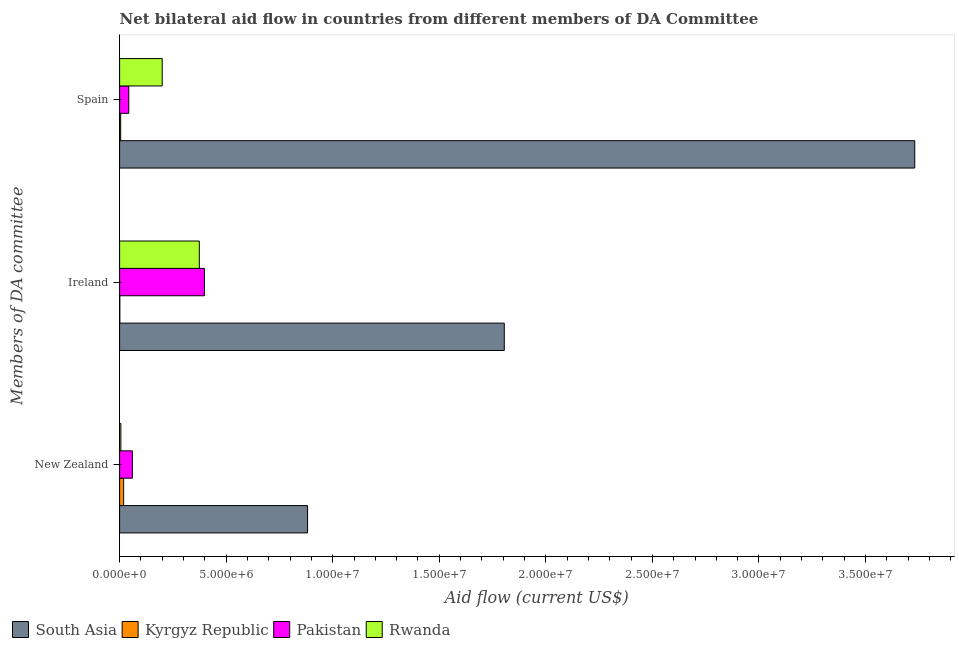Are the number of bars per tick equal to the number of legend labels?
Ensure brevity in your answer.  Yes. Are the number of bars on each tick of the Y-axis equal?
Make the answer very short. Yes. What is the label of the 1st group of bars from the top?
Provide a short and direct response. Spain. What is the amount of aid provided by spain in Kyrgyz Republic?
Keep it short and to the point. 5.00e+04. Across all countries, what is the maximum amount of aid provided by ireland?
Your response must be concise. 1.80e+07. Across all countries, what is the minimum amount of aid provided by ireland?
Keep it short and to the point. 10000. In which country was the amount of aid provided by new zealand minimum?
Ensure brevity in your answer.  Rwanda. What is the total amount of aid provided by ireland in the graph?
Your answer should be very brief. 2.58e+07. What is the difference between the amount of aid provided by ireland in South Asia and that in Pakistan?
Offer a terse response. 1.41e+07. What is the difference between the amount of aid provided by spain in South Asia and the amount of aid provided by ireland in Pakistan?
Your answer should be compact. 3.33e+07. What is the average amount of aid provided by spain per country?
Provide a short and direct response. 9.95e+06. What is the difference between the amount of aid provided by spain and amount of aid provided by ireland in Pakistan?
Your answer should be compact. -3.55e+06. In how many countries, is the amount of aid provided by spain greater than 24000000 US$?
Keep it short and to the point. 1. What is the ratio of the amount of aid provided by ireland in Kyrgyz Republic to that in South Asia?
Your response must be concise. 0. Is the difference between the amount of aid provided by ireland in Kyrgyz Republic and Rwanda greater than the difference between the amount of aid provided by new zealand in Kyrgyz Republic and Rwanda?
Give a very brief answer. No. What is the difference between the highest and the second highest amount of aid provided by new zealand?
Provide a succinct answer. 8.22e+06. What is the difference between the highest and the lowest amount of aid provided by spain?
Offer a terse response. 3.73e+07. What does the 3rd bar from the top in Spain represents?
Keep it short and to the point. Kyrgyz Republic. What does the 1st bar from the bottom in Ireland represents?
Provide a short and direct response. South Asia. Is it the case that in every country, the sum of the amount of aid provided by new zealand and amount of aid provided by ireland is greater than the amount of aid provided by spain?
Make the answer very short. No. What is the difference between two consecutive major ticks on the X-axis?
Provide a succinct answer. 5.00e+06. Does the graph contain any zero values?
Provide a short and direct response. No. How many legend labels are there?
Make the answer very short. 4. What is the title of the graph?
Offer a very short reply. Net bilateral aid flow in countries from different members of DA Committee. Does "Antigua and Barbuda" appear as one of the legend labels in the graph?
Your answer should be very brief. No. What is the label or title of the Y-axis?
Keep it short and to the point. Members of DA committee. What is the Aid flow (current US$) in South Asia in New Zealand?
Make the answer very short. 8.82e+06. What is the Aid flow (current US$) in Kyrgyz Republic in New Zealand?
Give a very brief answer. 1.90e+05. What is the Aid flow (current US$) in Pakistan in New Zealand?
Offer a terse response. 6.00e+05. What is the Aid flow (current US$) of Rwanda in New Zealand?
Offer a terse response. 6.00e+04. What is the Aid flow (current US$) in South Asia in Ireland?
Your answer should be very brief. 1.80e+07. What is the Aid flow (current US$) of Pakistan in Ireland?
Your response must be concise. 3.98e+06. What is the Aid flow (current US$) in Rwanda in Ireland?
Your answer should be compact. 3.74e+06. What is the Aid flow (current US$) of South Asia in Spain?
Keep it short and to the point. 3.73e+07. What is the Aid flow (current US$) in Pakistan in Spain?
Give a very brief answer. 4.30e+05. Across all Members of DA committee, what is the maximum Aid flow (current US$) of South Asia?
Provide a short and direct response. 3.73e+07. Across all Members of DA committee, what is the maximum Aid flow (current US$) in Pakistan?
Give a very brief answer. 3.98e+06. Across all Members of DA committee, what is the maximum Aid flow (current US$) in Rwanda?
Offer a very short reply. 3.74e+06. Across all Members of DA committee, what is the minimum Aid flow (current US$) of South Asia?
Your response must be concise. 8.82e+06. Across all Members of DA committee, what is the minimum Aid flow (current US$) of Kyrgyz Republic?
Your response must be concise. 10000. Across all Members of DA committee, what is the minimum Aid flow (current US$) of Rwanda?
Your answer should be very brief. 6.00e+04. What is the total Aid flow (current US$) in South Asia in the graph?
Make the answer very short. 6.42e+07. What is the total Aid flow (current US$) of Kyrgyz Republic in the graph?
Provide a succinct answer. 2.50e+05. What is the total Aid flow (current US$) of Pakistan in the graph?
Offer a very short reply. 5.01e+06. What is the total Aid flow (current US$) of Rwanda in the graph?
Offer a terse response. 5.80e+06. What is the difference between the Aid flow (current US$) of South Asia in New Zealand and that in Ireland?
Your response must be concise. -9.23e+06. What is the difference between the Aid flow (current US$) of Pakistan in New Zealand and that in Ireland?
Offer a terse response. -3.38e+06. What is the difference between the Aid flow (current US$) in Rwanda in New Zealand and that in Ireland?
Make the answer very short. -3.68e+06. What is the difference between the Aid flow (current US$) of South Asia in New Zealand and that in Spain?
Keep it short and to the point. -2.85e+07. What is the difference between the Aid flow (current US$) of Pakistan in New Zealand and that in Spain?
Your answer should be compact. 1.70e+05. What is the difference between the Aid flow (current US$) in Rwanda in New Zealand and that in Spain?
Your answer should be compact. -1.94e+06. What is the difference between the Aid flow (current US$) in South Asia in Ireland and that in Spain?
Give a very brief answer. -1.93e+07. What is the difference between the Aid flow (current US$) in Kyrgyz Republic in Ireland and that in Spain?
Your answer should be very brief. -4.00e+04. What is the difference between the Aid flow (current US$) in Pakistan in Ireland and that in Spain?
Your answer should be very brief. 3.55e+06. What is the difference between the Aid flow (current US$) of Rwanda in Ireland and that in Spain?
Ensure brevity in your answer.  1.74e+06. What is the difference between the Aid flow (current US$) in South Asia in New Zealand and the Aid flow (current US$) in Kyrgyz Republic in Ireland?
Your answer should be compact. 8.81e+06. What is the difference between the Aid flow (current US$) in South Asia in New Zealand and the Aid flow (current US$) in Pakistan in Ireland?
Keep it short and to the point. 4.84e+06. What is the difference between the Aid flow (current US$) in South Asia in New Zealand and the Aid flow (current US$) in Rwanda in Ireland?
Ensure brevity in your answer.  5.08e+06. What is the difference between the Aid flow (current US$) in Kyrgyz Republic in New Zealand and the Aid flow (current US$) in Pakistan in Ireland?
Your answer should be very brief. -3.79e+06. What is the difference between the Aid flow (current US$) of Kyrgyz Republic in New Zealand and the Aid flow (current US$) of Rwanda in Ireland?
Give a very brief answer. -3.55e+06. What is the difference between the Aid flow (current US$) of Pakistan in New Zealand and the Aid flow (current US$) of Rwanda in Ireland?
Keep it short and to the point. -3.14e+06. What is the difference between the Aid flow (current US$) in South Asia in New Zealand and the Aid flow (current US$) in Kyrgyz Republic in Spain?
Offer a terse response. 8.77e+06. What is the difference between the Aid flow (current US$) in South Asia in New Zealand and the Aid flow (current US$) in Pakistan in Spain?
Your answer should be very brief. 8.39e+06. What is the difference between the Aid flow (current US$) in South Asia in New Zealand and the Aid flow (current US$) in Rwanda in Spain?
Provide a succinct answer. 6.82e+06. What is the difference between the Aid flow (current US$) in Kyrgyz Republic in New Zealand and the Aid flow (current US$) in Pakistan in Spain?
Offer a terse response. -2.40e+05. What is the difference between the Aid flow (current US$) of Kyrgyz Republic in New Zealand and the Aid flow (current US$) of Rwanda in Spain?
Provide a succinct answer. -1.81e+06. What is the difference between the Aid flow (current US$) in Pakistan in New Zealand and the Aid flow (current US$) in Rwanda in Spain?
Give a very brief answer. -1.40e+06. What is the difference between the Aid flow (current US$) of South Asia in Ireland and the Aid flow (current US$) of Kyrgyz Republic in Spain?
Keep it short and to the point. 1.80e+07. What is the difference between the Aid flow (current US$) in South Asia in Ireland and the Aid flow (current US$) in Pakistan in Spain?
Offer a terse response. 1.76e+07. What is the difference between the Aid flow (current US$) of South Asia in Ireland and the Aid flow (current US$) of Rwanda in Spain?
Your answer should be compact. 1.60e+07. What is the difference between the Aid flow (current US$) in Kyrgyz Republic in Ireland and the Aid flow (current US$) in Pakistan in Spain?
Provide a succinct answer. -4.20e+05. What is the difference between the Aid flow (current US$) in Kyrgyz Republic in Ireland and the Aid flow (current US$) in Rwanda in Spain?
Keep it short and to the point. -1.99e+06. What is the difference between the Aid flow (current US$) of Pakistan in Ireland and the Aid flow (current US$) of Rwanda in Spain?
Provide a succinct answer. 1.98e+06. What is the average Aid flow (current US$) in South Asia per Members of DA committee?
Give a very brief answer. 2.14e+07. What is the average Aid flow (current US$) of Kyrgyz Republic per Members of DA committee?
Your answer should be very brief. 8.33e+04. What is the average Aid flow (current US$) of Pakistan per Members of DA committee?
Provide a succinct answer. 1.67e+06. What is the average Aid flow (current US$) of Rwanda per Members of DA committee?
Provide a succinct answer. 1.93e+06. What is the difference between the Aid flow (current US$) in South Asia and Aid flow (current US$) in Kyrgyz Republic in New Zealand?
Give a very brief answer. 8.63e+06. What is the difference between the Aid flow (current US$) in South Asia and Aid flow (current US$) in Pakistan in New Zealand?
Offer a terse response. 8.22e+06. What is the difference between the Aid flow (current US$) in South Asia and Aid flow (current US$) in Rwanda in New Zealand?
Your answer should be compact. 8.76e+06. What is the difference between the Aid flow (current US$) of Kyrgyz Republic and Aid flow (current US$) of Pakistan in New Zealand?
Your response must be concise. -4.10e+05. What is the difference between the Aid flow (current US$) of Pakistan and Aid flow (current US$) of Rwanda in New Zealand?
Give a very brief answer. 5.40e+05. What is the difference between the Aid flow (current US$) of South Asia and Aid flow (current US$) of Kyrgyz Republic in Ireland?
Offer a very short reply. 1.80e+07. What is the difference between the Aid flow (current US$) in South Asia and Aid flow (current US$) in Pakistan in Ireland?
Your answer should be compact. 1.41e+07. What is the difference between the Aid flow (current US$) of South Asia and Aid flow (current US$) of Rwanda in Ireland?
Provide a succinct answer. 1.43e+07. What is the difference between the Aid flow (current US$) of Kyrgyz Republic and Aid flow (current US$) of Pakistan in Ireland?
Provide a succinct answer. -3.97e+06. What is the difference between the Aid flow (current US$) of Kyrgyz Republic and Aid flow (current US$) of Rwanda in Ireland?
Provide a succinct answer. -3.73e+06. What is the difference between the Aid flow (current US$) of Pakistan and Aid flow (current US$) of Rwanda in Ireland?
Your answer should be very brief. 2.40e+05. What is the difference between the Aid flow (current US$) in South Asia and Aid flow (current US$) in Kyrgyz Republic in Spain?
Offer a very short reply. 3.73e+07. What is the difference between the Aid flow (current US$) in South Asia and Aid flow (current US$) in Pakistan in Spain?
Provide a short and direct response. 3.69e+07. What is the difference between the Aid flow (current US$) of South Asia and Aid flow (current US$) of Rwanda in Spain?
Your answer should be very brief. 3.53e+07. What is the difference between the Aid flow (current US$) in Kyrgyz Republic and Aid flow (current US$) in Pakistan in Spain?
Your answer should be very brief. -3.80e+05. What is the difference between the Aid flow (current US$) of Kyrgyz Republic and Aid flow (current US$) of Rwanda in Spain?
Offer a terse response. -1.95e+06. What is the difference between the Aid flow (current US$) in Pakistan and Aid flow (current US$) in Rwanda in Spain?
Provide a short and direct response. -1.57e+06. What is the ratio of the Aid flow (current US$) in South Asia in New Zealand to that in Ireland?
Your response must be concise. 0.49. What is the ratio of the Aid flow (current US$) of Kyrgyz Republic in New Zealand to that in Ireland?
Your answer should be very brief. 19. What is the ratio of the Aid flow (current US$) in Pakistan in New Zealand to that in Ireland?
Ensure brevity in your answer.  0.15. What is the ratio of the Aid flow (current US$) in Rwanda in New Zealand to that in Ireland?
Offer a terse response. 0.02. What is the ratio of the Aid flow (current US$) of South Asia in New Zealand to that in Spain?
Keep it short and to the point. 0.24. What is the ratio of the Aid flow (current US$) of Kyrgyz Republic in New Zealand to that in Spain?
Provide a short and direct response. 3.8. What is the ratio of the Aid flow (current US$) of Pakistan in New Zealand to that in Spain?
Keep it short and to the point. 1.4. What is the ratio of the Aid flow (current US$) in South Asia in Ireland to that in Spain?
Give a very brief answer. 0.48. What is the ratio of the Aid flow (current US$) in Pakistan in Ireland to that in Spain?
Give a very brief answer. 9.26. What is the ratio of the Aid flow (current US$) in Rwanda in Ireland to that in Spain?
Provide a short and direct response. 1.87. What is the difference between the highest and the second highest Aid flow (current US$) in South Asia?
Your answer should be very brief. 1.93e+07. What is the difference between the highest and the second highest Aid flow (current US$) of Kyrgyz Republic?
Provide a succinct answer. 1.40e+05. What is the difference between the highest and the second highest Aid flow (current US$) in Pakistan?
Your answer should be very brief. 3.38e+06. What is the difference between the highest and the second highest Aid flow (current US$) of Rwanda?
Make the answer very short. 1.74e+06. What is the difference between the highest and the lowest Aid flow (current US$) of South Asia?
Ensure brevity in your answer.  2.85e+07. What is the difference between the highest and the lowest Aid flow (current US$) in Pakistan?
Keep it short and to the point. 3.55e+06. What is the difference between the highest and the lowest Aid flow (current US$) of Rwanda?
Your response must be concise. 3.68e+06. 